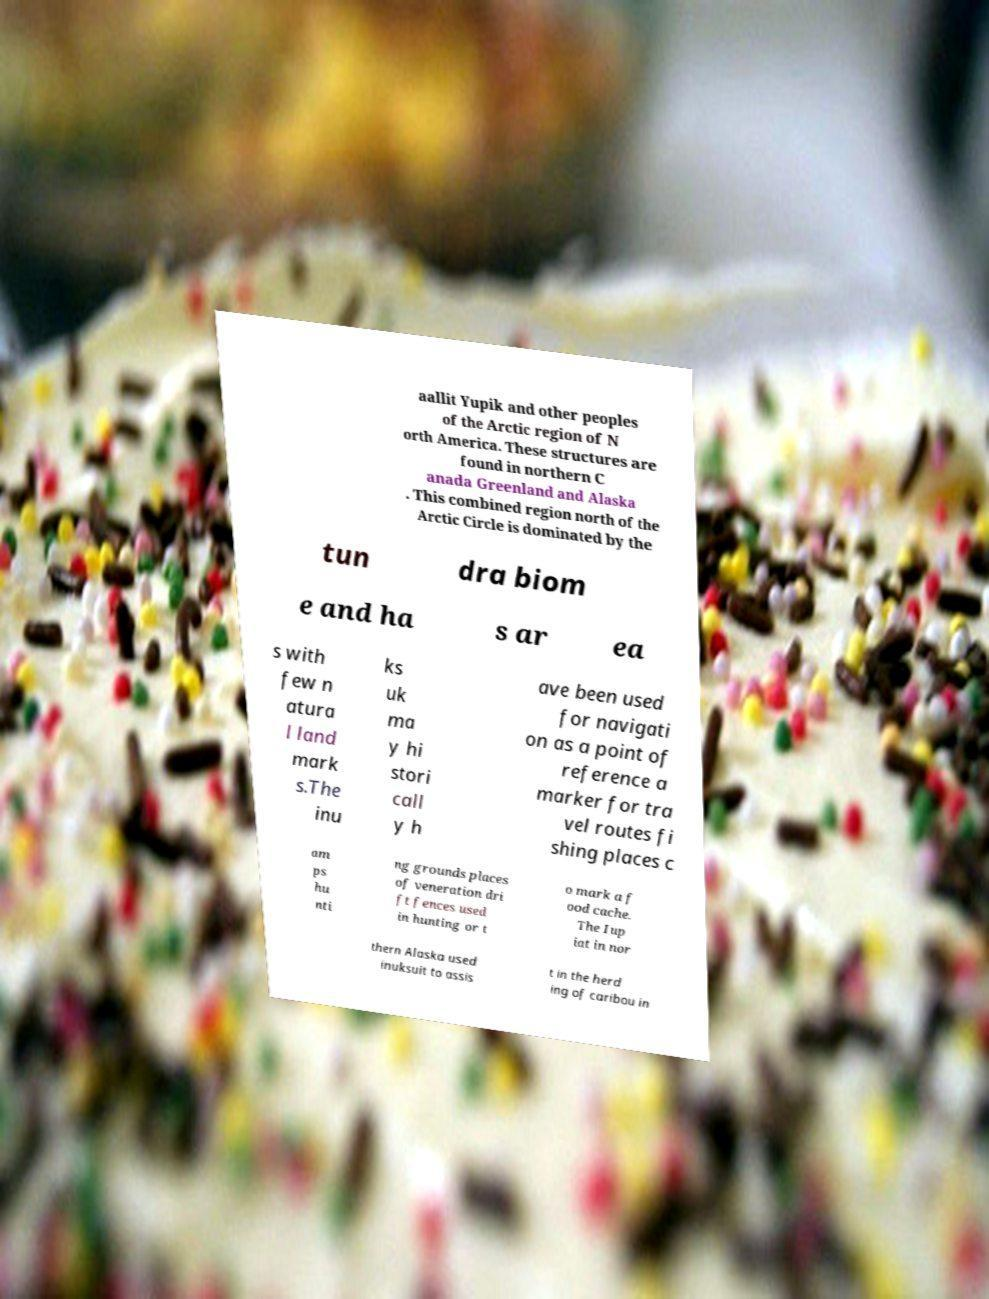Can you read and provide the text displayed in the image?This photo seems to have some interesting text. Can you extract and type it out for me? aallit Yupik and other peoples of the Arctic region of N orth America. These structures are found in northern C anada Greenland and Alaska . This combined region north of the Arctic Circle is dominated by the tun dra biom e and ha s ar ea s with few n atura l land mark s.The inu ks uk ma y hi stori call y h ave been used for navigati on as a point of reference a marker for tra vel routes fi shing places c am ps hu nti ng grounds places of veneration dri ft fences used in hunting or t o mark a f ood cache. The Iup iat in nor thern Alaska used inuksuit to assis t in the herd ing of caribou in 